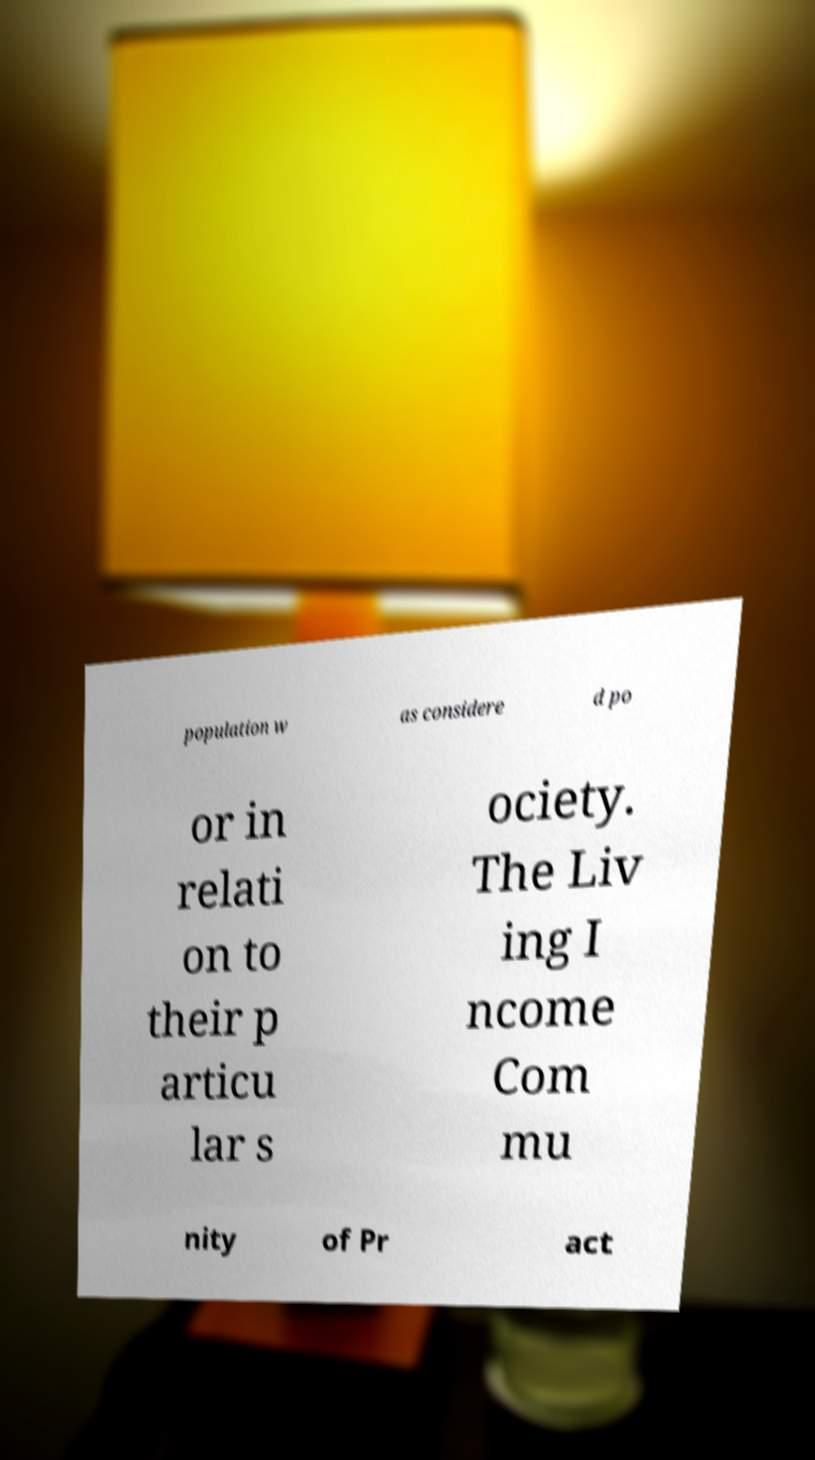For documentation purposes, I need the text within this image transcribed. Could you provide that? population w as considere d po or in relati on to their p articu lar s ociety. The Liv ing I ncome Com mu nity of Pr act 